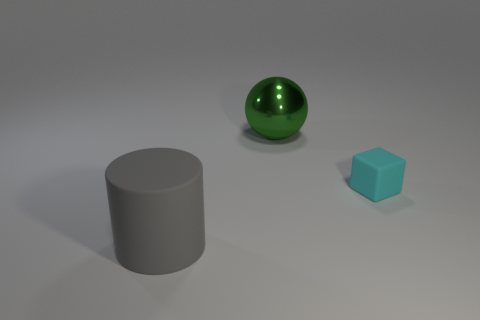How are the objects positioned in relation to each other? The objects are positioned on a flat surface with the green sphere to the left, the gray cylinder at the center, and the blue cube to the right.  Is there any pattern or symmetry in the arrangement of objects? The objects are arranged asymmetrically and there is no apparent pattern or intentional symmetry in their placement. 